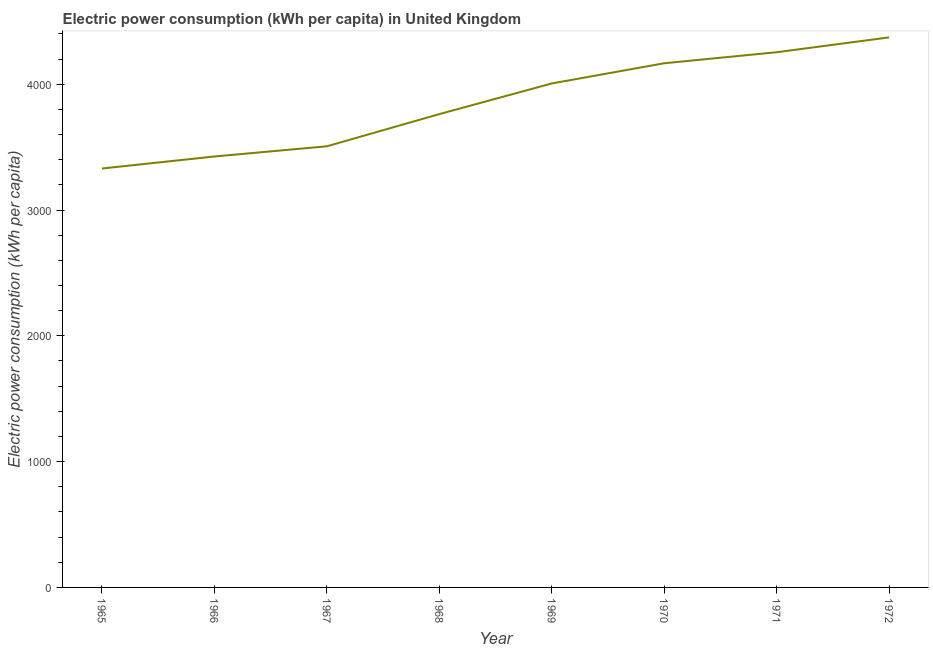What is the electric power consumption in 1969?
Make the answer very short. 4006.33. Across all years, what is the maximum electric power consumption?
Ensure brevity in your answer.  4372.64. Across all years, what is the minimum electric power consumption?
Keep it short and to the point. 3330.18. In which year was the electric power consumption minimum?
Offer a very short reply. 1965. What is the sum of the electric power consumption?
Your answer should be very brief. 3.08e+04. What is the difference between the electric power consumption in 1970 and 1971?
Make the answer very short. -87.72. What is the average electric power consumption per year?
Provide a succinct answer. 3853.25. What is the median electric power consumption?
Your answer should be very brief. 3884.46. In how many years, is the electric power consumption greater than 3800 kWh per capita?
Your answer should be compact. 4. Do a majority of the years between 1966 and 1969 (inclusive) have electric power consumption greater than 200 kWh per capita?
Your response must be concise. Yes. What is the ratio of the electric power consumption in 1965 to that in 1967?
Keep it short and to the point. 0.95. Is the electric power consumption in 1966 less than that in 1971?
Keep it short and to the point. Yes. Is the difference between the electric power consumption in 1966 and 1972 greater than the difference between any two years?
Offer a terse response. No. What is the difference between the highest and the second highest electric power consumption?
Your answer should be compact. 117.98. Is the sum of the electric power consumption in 1968 and 1969 greater than the maximum electric power consumption across all years?
Offer a terse response. Yes. What is the difference between the highest and the lowest electric power consumption?
Give a very brief answer. 1042.45. In how many years, is the electric power consumption greater than the average electric power consumption taken over all years?
Provide a succinct answer. 4. Does the electric power consumption monotonically increase over the years?
Offer a very short reply. Yes. What is the difference between two consecutive major ticks on the Y-axis?
Your response must be concise. 1000. Are the values on the major ticks of Y-axis written in scientific E-notation?
Give a very brief answer. No. Does the graph contain any zero values?
Your answer should be compact. No. Does the graph contain grids?
Your response must be concise. No. What is the title of the graph?
Your answer should be compact. Electric power consumption (kWh per capita) in United Kingdom. What is the label or title of the Y-axis?
Offer a very short reply. Electric power consumption (kWh per capita). What is the Electric power consumption (kWh per capita) in 1965?
Make the answer very short. 3330.18. What is the Electric power consumption (kWh per capita) in 1966?
Give a very brief answer. 3425.8. What is the Electric power consumption (kWh per capita) in 1967?
Your answer should be very brief. 3506.89. What is the Electric power consumption (kWh per capita) of 1968?
Provide a short and direct response. 3762.59. What is the Electric power consumption (kWh per capita) of 1969?
Give a very brief answer. 4006.33. What is the Electric power consumption (kWh per capita) of 1970?
Offer a very short reply. 4166.93. What is the Electric power consumption (kWh per capita) in 1971?
Offer a very short reply. 4254.65. What is the Electric power consumption (kWh per capita) of 1972?
Keep it short and to the point. 4372.64. What is the difference between the Electric power consumption (kWh per capita) in 1965 and 1966?
Ensure brevity in your answer.  -95.62. What is the difference between the Electric power consumption (kWh per capita) in 1965 and 1967?
Your answer should be very brief. -176.7. What is the difference between the Electric power consumption (kWh per capita) in 1965 and 1968?
Provide a succinct answer. -432.41. What is the difference between the Electric power consumption (kWh per capita) in 1965 and 1969?
Provide a short and direct response. -676.15. What is the difference between the Electric power consumption (kWh per capita) in 1965 and 1970?
Give a very brief answer. -836.75. What is the difference between the Electric power consumption (kWh per capita) in 1965 and 1971?
Provide a succinct answer. -924.47. What is the difference between the Electric power consumption (kWh per capita) in 1965 and 1972?
Make the answer very short. -1042.45. What is the difference between the Electric power consumption (kWh per capita) in 1966 and 1967?
Offer a terse response. -81.08. What is the difference between the Electric power consumption (kWh per capita) in 1966 and 1968?
Ensure brevity in your answer.  -336.79. What is the difference between the Electric power consumption (kWh per capita) in 1966 and 1969?
Provide a short and direct response. -580.53. What is the difference between the Electric power consumption (kWh per capita) in 1966 and 1970?
Offer a terse response. -741.13. What is the difference between the Electric power consumption (kWh per capita) in 1966 and 1971?
Offer a terse response. -828.85. What is the difference between the Electric power consumption (kWh per capita) in 1966 and 1972?
Make the answer very short. -946.83. What is the difference between the Electric power consumption (kWh per capita) in 1967 and 1968?
Keep it short and to the point. -255.7. What is the difference between the Electric power consumption (kWh per capita) in 1967 and 1969?
Your response must be concise. -499.44. What is the difference between the Electric power consumption (kWh per capita) in 1967 and 1970?
Your answer should be compact. -660.05. What is the difference between the Electric power consumption (kWh per capita) in 1967 and 1971?
Offer a very short reply. -747.77. What is the difference between the Electric power consumption (kWh per capita) in 1967 and 1972?
Offer a terse response. -865.75. What is the difference between the Electric power consumption (kWh per capita) in 1968 and 1969?
Provide a short and direct response. -243.74. What is the difference between the Electric power consumption (kWh per capita) in 1968 and 1970?
Your answer should be compact. -404.34. What is the difference between the Electric power consumption (kWh per capita) in 1968 and 1971?
Your answer should be compact. -492.06. What is the difference between the Electric power consumption (kWh per capita) in 1968 and 1972?
Provide a short and direct response. -610.05. What is the difference between the Electric power consumption (kWh per capita) in 1969 and 1970?
Your answer should be compact. -160.6. What is the difference between the Electric power consumption (kWh per capita) in 1969 and 1971?
Your answer should be very brief. -248.32. What is the difference between the Electric power consumption (kWh per capita) in 1969 and 1972?
Make the answer very short. -366.31. What is the difference between the Electric power consumption (kWh per capita) in 1970 and 1971?
Provide a succinct answer. -87.72. What is the difference between the Electric power consumption (kWh per capita) in 1970 and 1972?
Make the answer very short. -205.7. What is the difference between the Electric power consumption (kWh per capita) in 1971 and 1972?
Your response must be concise. -117.98. What is the ratio of the Electric power consumption (kWh per capita) in 1965 to that in 1966?
Your response must be concise. 0.97. What is the ratio of the Electric power consumption (kWh per capita) in 1965 to that in 1967?
Your answer should be very brief. 0.95. What is the ratio of the Electric power consumption (kWh per capita) in 1965 to that in 1968?
Provide a succinct answer. 0.89. What is the ratio of the Electric power consumption (kWh per capita) in 1965 to that in 1969?
Keep it short and to the point. 0.83. What is the ratio of the Electric power consumption (kWh per capita) in 1965 to that in 1970?
Your answer should be compact. 0.8. What is the ratio of the Electric power consumption (kWh per capita) in 1965 to that in 1971?
Your answer should be compact. 0.78. What is the ratio of the Electric power consumption (kWh per capita) in 1965 to that in 1972?
Offer a very short reply. 0.76. What is the ratio of the Electric power consumption (kWh per capita) in 1966 to that in 1967?
Your answer should be compact. 0.98. What is the ratio of the Electric power consumption (kWh per capita) in 1966 to that in 1968?
Give a very brief answer. 0.91. What is the ratio of the Electric power consumption (kWh per capita) in 1966 to that in 1969?
Your response must be concise. 0.85. What is the ratio of the Electric power consumption (kWh per capita) in 1966 to that in 1970?
Offer a very short reply. 0.82. What is the ratio of the Electric power consumption (kWh per capita) in 1966 to that in 1971?
Your answer should be compact. 0.81. What is the ratio of the Electric power consumption (kWh per capita) in 1966 to that in 1972?
Your response must be concise. 0.78. What is the ratio of the Electric power consumption (kWh per capita) in 1967 to that in 1968?
Your answer should be compact. 0.93. What is the ratio of the Electric power consumption (kWh per capita) in 1967 to that in 1970?
Your answer should be compact. 0.84. What is the ratio of the Electric power consumption (kWh per capita) in 1967 to that in 1971?
Offer a very short reply. 0.82. What is the ratio of the Electric power consumption (kWh per capita) in 1967 to that in 1972?
Provide a short and direct response. 0.8. What is the ratio of the Electric power consumption (kWh per capita) in 1968 to that in 1969?
Provide a short and direct response. 0.94. What is the ratio of the Electric power consumption (kWh per capita) in 1968 to that in 1970?
Provide a short and direct response. 0.9. What is the ratio of the Electric power consumption (kWh per capita) in 1968 to that in 1971?
Offer a terse response. 0.88. What is the ratio of the Electric power consumption (kWh per capita) in 1968 to that in 1972?
Your answer should be compact. 0.86. What is the ratio of the Electric power consumption (kWh per capita) in 1969 to that in 1971?
Ensure brevity in your answer.  0.94. What is the ratio of the Electric power consumption (kWh per capita) in 1969 to that in 1972?
Provide a short and direct response. 0.92. What is the ratio of the Electric power consumption (kWh per capita) in 1970 to that in 1972?
Provide a succinct answer. 0.95. What is the ratio of the Electric power consumption (kWh per capita) in 1971 to that in 1972?
Your answer should be very brief. 0.97. 